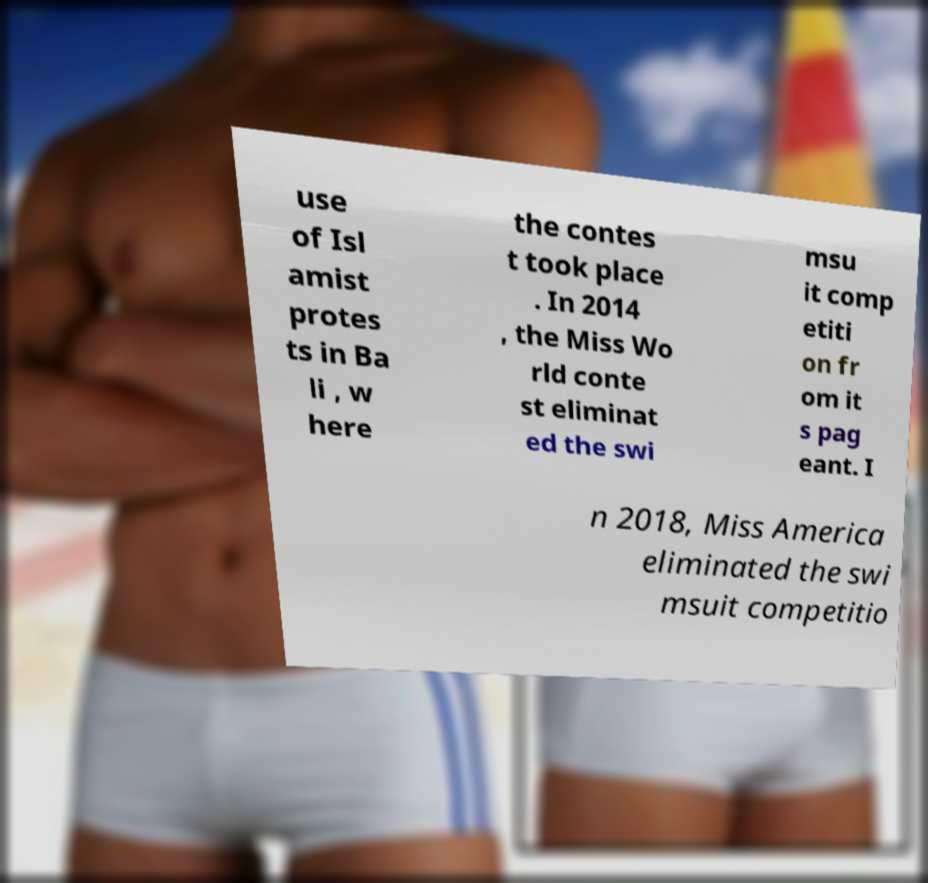Could you assist in decoding the text presented in this image and type it out clearly? use of Isl amist protes ts in Ba li , w here the contes t took place . In 2014 , the Miss Wo rld conte st eliminat ed the swi msu it comp etiti on fr om it s pag eant. I n 2018, Miss America eliminated the swi msuit competitio 